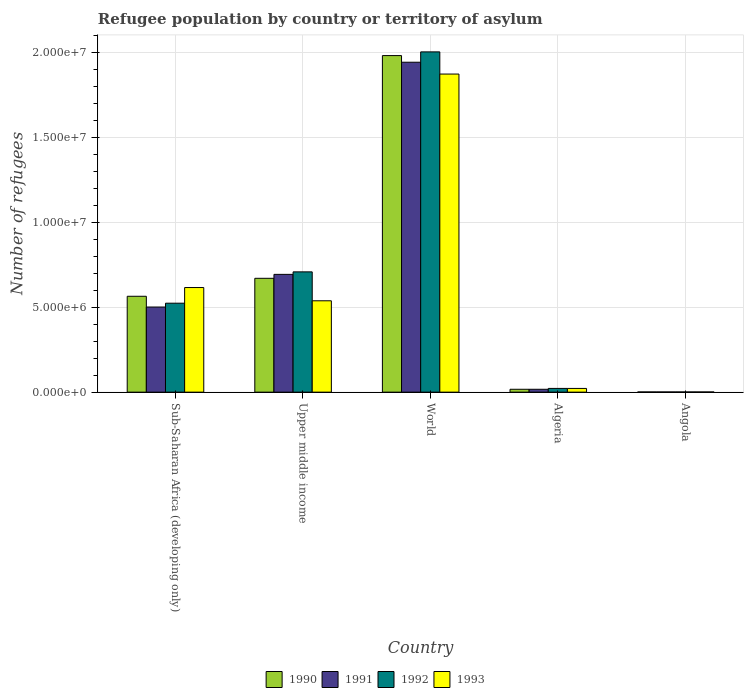Are the number of bars on each tick of the X-axis equal?
Offer a very short reply. Yes. What is the label of the 4th group of bars from the left?
Provide a short and direct response. Algeria. What is the number of refugees in 1991 in Upper middle income?
Offer a terse response. 6.93e+06. Across all countries, what is the maximum number of refugees in 1990?
Your answer should be very brief. 1.98e+07. Across all countries, what is the minimum number of refugees in 1991?
Your answer should be compact. 1.10e+04. In which country was the number of refugees in 1992 minimum?
Your answer should be compact. Angola. What is the total number of refugees in 1992 in the graph?
Make the answer very short. 3.26e+07. What is the difference between the number of refugees in 1993 in Angola and that in World?
Offer a terse response. -1.87e+07. What is the difference between the number of refugees in 1993 in Upper middle income and the number of refugees in 1990 in World?
Your answer should be compact. -1.44e+07. What is the average number of refugees in 1993 per country?
Keep it short and to the point. 6.10e+06. What is the ratio of the number of refugees in 1992 in Angola to that in Upper middle income?
Make the answer very short. 0. What is the difference between the highest and the second highest number of refugees in 1992?
Offer a terse response. -1.29e+07. What is the difference between the highest and the lowest number of refugees in 1992?
Provide a short and direct response. 2.00e+07. Is the sum of the number of refugees in 1992 in Algeria and Sub-Saharan Africa (developing only) greater than the maximum number of refugees in 1991 across all countries?
Your response must be concise. No. What does the 1st bar from the left in Algeria represents?
Offer a terse response. 1990. Is it the case that in every country, the sum of the number of refugees in 1992 and number of refugees in 1991 is greater than the number of refugees in 1990?
Keep it short and to the point. Yes. How many countries are there in the graph?
Your answer should be very brief. 5. Does the graph contain grids?
Make the answer very short. Yes. Where does the legend appear in the graph?
Your response must be concise. Bottom center. How many legend labels are there?
Offer a terse response. 4. How are the legend labels stacked?
Offer a terse response. Horizontal. What is the title of the graph?
Your answer should be very brief. Refugee population by country or territory of asylum. Does "2000" appear as one of the legend labels in the graph?
Your answer should be compact. No. What is the label or title of the Y-axis?
Keep it short and to the point. Number of refugees. What is the Number of refugees in 1990 in Sub-Saharan Africa (developing only)?
Make the answer very short. 5.64e+06. What is the Number of refugees of 1991 in Sub-Saharan Africa (developing only)?
Offer a terse response. 5.01e+06. What is the Number of refugees of 1992 in Sub-Saharan Africa (developing only)?
Your answer should be very brief. 5.23e+06. What is the Number of refugees in 1993 in Sub-Saharan Africa (developing only)?
Your response must be concise. 6.16e+06. What is the Number of refugees of 1990 in Upper middle income?
Provide a succinct answer. 6.70e+06. What is the Number of refugees in 1991 in Upper middle income?
Give a very brief answer. 6.93e+06. What is the Number of refugees of 1992 in Upper middle income?
Your answer should be very brief. 7.08e+06. What is the Number of refugees in 1993 in Upper middle income?
Provide a succinct answer. 5.38e+06. What is the Number of refugees in 1990 in World?
Keep it short and to the point. 1.98e+07. What is the Number of refugees in 1991 in World?
Offer a terse response. 1.94e+07. What is the Number of refugees of 1992 in World?
Your answer should be very brief. 2.00e+07. What is the Number of refugees in 1993 in World?
Offer a terse response. 1.87e+07. What is the Number of refugees in 1990 in Algeria?
Make the answer very short. 1.69e+05. What is the Number of refugees of 1991 in Algeria?
Offer a very short reply. 1.69e+05. What is the Number of refugees of 1992 in Algeria?
Provide a short and direct response. 2.19e+05. What is the Number of refugees in 1993 in Algeria?
Make the answer very short. 2.19e+05. What is the Number of refugees in 1990 in Angola?
Provide a short and direct response. 1.16e+04. What is the Number of refugees of 1991 in Angola?
Ensure brevity in your answer.  1.10e+04. What is the Number of refugees of 1992 in Angola?
Your answer should be very brief. 1.10e+04. What is the Number of refugees in 1993 in Angola?
Give a very brief answer. 1.09e+04. Across all countries, what is the maximum Number of refugees of 1990?
Give a very brief answer. 1.98e+07. Across all countries, what is the maximum Number of refugees of 1991?
Provide a short and direct response. 1.94e+07. Across all countries, what is the maximum Number of refugees of 1992?
Keep it short and to the point. 2.00e+07. Across all countries, what is the maximum Number of refugees in 1993?
Offer a very short reply. 1.87e+07. Across all countries, what is the minimum Number of refugees in 1990?
Your answer should be very brief. 1.16e+04. Across all countries, what is the minimum Number of refugees in 1991?
Provide a succinct answer. 1.10e+04. Across all countries, what is the minimum Number of refugees in 1992?
Make the answer very short. 1.10e+04. Across all countries, what is the minimum Number of refugees in 1993?
Make the answer very short. 1.09e+04. What is the total Number of refugees of 1990 in the graph?
Your answer should be compact. 3.23e+07. What is the total Number of refugees of 1991 in the graph?
Provide a short and direct response. 3.15e+07. What is the total Number of refugees of 1992 in the graph?
Offer a terse response. 3.26e+07. What is the total Number of refugees of 1993 in the graph?
Provide a short and direct response. 3.05e+07. What is the difference between the Number of refugees of 1990 in Sub-Saharan Africa (developing only) and that in Upper middle income?
Your answer should be very brief. -1.06e+06. What is the difference between the Number of refugees of 1991 in Sub-Saharan Africa (developing only) and that in Upper middle income?
Provide a succinct answer. -1.92e+06. What is the difference between the Number of refugees of 1992 in Sub-Saharan Africa (developing only) and that in Upper middle income?
Provide a short and direct response. -1.84e+06. What is the difference between the Number of refugees of 1993 in Sub-Saharan Africa (developing only) and that in Upper middle income?
Make the answer very short. 7.79e+05. What is the difference between the Number of refugees in 1990 in Sub-Saharan Africa (developing only) and that in World?
Your response must be concise. -1.42e+07. What is the difference between the Number of refugees of 1991 in Sub-Saharan Africa (developing only) and that in World?
Ensure brevity in your answer.  -1.44e+07. What is the difference between the Number of refugees of 1992 in Sub-Saharan Africa (developing only) and that in World?
Provide a succinct answer. -1.48e+07. What is the difference between the Number of refugees of 1993 in Sub-Saharan Africa (developing only) and that in World?
Provide a short and direct response. -1.26e+07. What is the difference between the Number of refugees of 1990 in Sub-Saharan Africa (developing only) and that in Algeria?
Keep it short and to the point. 5.47e+06. What is the difference between the Number of refugees of 1991 in Sub-Saharan Africa (developing only) and that in Algeria?
Offer a very short reply. 4.84e+06. What is the difference between the Number of refugees of 1992 in Sub-Saharan Africa (developing only) and that in Algeria?
Offer a very short reply. 5.01e+06. What is the difference between the Number of refugees in 1993 in Sub-Saharan Africa (developing only) and that in Algeria?
Ensure brevity in your answer.  5.94e+06. What is the difference between the Number of refugees of 1990 in Sub-Saharan Africa (developing only) and that in Angola?
Make the answer very short. 5.63e+06. What is the difference between the Number of refugees of 1991 in Sub-Saharan Africa (developing only) and that in Angola?
Offer a terse response. 5.00e+06. What is the difference between the Number of refugees of 1992 in Sub-Saharan Africa (developing only) and that in Angola?
Give a very brief answer. 5.22e+06. What is the difference between the Number of refugees of 1993 in Sub-Saharan Africa (developing only) and that in Angola?
Your answer should be very brief. 6.14e+06. What is the difference between the Number of refugees in 1990 in Upper middle income and that in World?
Your response must be concise. -1.31e+07. What is the difference between the Number of refugees of 1991 in Upper middle income and that in World?
Give a very brief answer. -1.25e+07. What is the difference between the Number of refugees in 1992 in Upper middle income and that in World?
Provide a succinct answer. -1.29e+07. What is the difference between the Number of refugees in 1993 in Upper middle income and that in World?
Your answer should be very brief. -1.33e+07. What is the difference between the Number of refugees in 1990 in Upper middle income and that in Algeria?
Provide a short and direct response. 6.53e+06. What is the difference between the Number of refugees of 1991 in Upper middle income and that in Algeria?
Give a very brief answer. 6.76e+06. What is the difference between the Number of refugees of 1992 in Upper middle income and that in Algeria?
Offer a terse response. 6.86e+06. What is the difference between the Number of refugees of 1993 in Upper middle income and that in Algeria?
Give a very brief answer. 5.16e+06. What is the difference between the Number of refugees in 1990 in Upper middle income and that in Angola?
Keep it short and to the point. 6.69e+06. What is the difference between the Number of refugees of 1991 in Upper middle income and that in Angola?
Your answer should be very brief. 6.92e+06. What is the difference between the Number of refugees of 1992 in Upper middle income and that in Angola?
Offer a terse response. 7.07e+06. What is the difference between the Number of refugees in 1993 in Upper middle income and that in Angola?
Offer a very short reply. 5.37e+06. What is the difference between the Number of refugees of 1990 in World and that in Algeria?
Keep it short and to the point. 1.96e+07. What is the difference between the Number of refugees in 1991 in World and that in Algeria?
Offer a very short reply. 1.92e+07. What is the difference between the Number of refugees of 1992 in World and that in Algeria?
Your answer should be very brief. 1.98e+07. What is the difference between the Number of refugees in 1993 in World and that in Algeria?
Keep it short and to the point. 1.85e+07. What is the difference between the Number of refugees of 1990 in World and that in Angola?
Provide a short and direct response. 1.98e+07. What is the difference between the Number of refugees in 1991 in World and that in Angola?
Your answer should be very brief. 1.94e+07. What is the difference between the Number of refugees in 1992 in World and that in Angola?
Keep it short and to the point. 2.00e+07. What is the difference between the Number of refugees in 1993 in World and that in Angola?
Your answer should be very brief. 1.87e+07. What is the difference between the Number of refugees in 1990 in Algeria and that in Angola?
Offer a terse response. 1.58e+05. What is the difference between the Number of refugees of 1991 in Algeria and that in Angola?
Offer a very short reply. 1.58e+05. What is the difference between the Number of refugees in 1992 in Algeria and that in Angola?
Offer a very short reply. 2.08e+05. What is the difference between the Number of refugees in 1993 in Algeria and that in Angola?
Offer a very short reply. 2.08e+05. What is the difference between the Number of refugees of 1990 in Sub-Saharan Africa (developing only) and the Number of refugees of 1991 in Upper middle income?
Provide a succinct answer. -1.29e+06. What is the difference between the Number of refugees in 1990 in Sub-Saharan Africa (developing only) and the Number of refugees in 1992 in Upper middle income?
Ensure brevity in your answer.  -1.44e+06. What is the difference between the Number of refugees in 1990 in Sub-Saharan Africa (developing only) and the Number of refugees in 1993 in Upper middle income?
Give a very brief answer. 2.65e+05. What is the difference between the Number of refugees in 1991 in Sub-Saharan Africa (developing only) and the Number of refugees in 1992 in Upper middle income?
Offer a very short reply. -2.07e+06. What is the difference between the Number of refugees in 1991 in Sub-Saharan Africa (developing only) and the Number of refugees in 1993 in Upper middle income?
Provide a succinct answer. -3.67e+05. What is the difference between the Number of refugees of 1992 in Sub-Saharan Africa (developing only) and the Number of refugees of 1993 in Upper middle income?
Ensure brevity in your answer.  -1.42e+05. What is the difference between the Number of refugees of 1990 in Sub-Saharan Africa (developing only) and the Number of refugees of 1991 in World?
Give a very brief answer. -1.38e+07. What is the difference between the Number of refugees of 1990 in Sub-Saharan Africa (developing only) and the Number of refugees of 1992 in World?
Your answer should be compact. -1.44e+07. What is the difference between the Number of refugees in 1990 in Sub-Saharan Africa (developing only) and the Number of refugees in 1993 in World?
Give a very brief answer. -1.31e+07. What is the difference between the Number of refugees in 1991 in Sub-Saharan Africa (developing only) and the Number of refugees in 1992 in World?
Offer a very short reply. -1.50e+07. What is the difference between the Number of refugees in 1991 in Sub-Saharan Africa (developing only) and the Number of refugees in 1993 in World?
Offer a terse response. -1.37e+07. What is the difference between the Number of refugees of 1992 in Sub-Saharan Africa (developing only) and the Number of refugees of 1993 in World?
Provide a succinct answer. -1.35e+07. What is the difference between the Number of refugees of 1990 in Sub-Saharan Africa (developing only) and the Number of refugees of 1991 in Algeria?
Your answer should be very brief. 5.47e+06. What is the difference between the Number of refugees of 1990 in Sub-Saharan Africa (developing only) and the Number of refugees of 1992 in Algeria?
Your answer should be very brief. 5.42e+06. What is the difference between the Number of refugees in 1990 in Sub-Saharan Africa (developing only) and the Number of refugees in 1993 in Algeria?
Provide a short and direct response. 5.42e+06. What is the difference between the Number of refugees of 1991 in Sub-Saharan Africa (developing only) and the Number of refugees of 1992 in Algeria?
Give a very brief answer. 4.79e+06. What is the difference between the Number of refugees in 1991 in Sub-Saharan Africa (developing only) and the Number of refugees in 1993 in Algeria?
Provide a short and direct response. 4.79e+06. What is the difference between the Number of refugees in 1992 in Sub-Saharan Africa (developing only) and the Number of refugees in 1993 in Algeria?
Make the answer very short. 5.02e+06. What is the difference between the Number of refugees of 1990 in Sub-Saharan Africa (developing only) and the Number of refugees of 1991 in Angola?
Your answer should be very brief. 5.63e+06. What is the difference between the Number of refugees in 1990 in Sub-Saharan Africa (developing only) and the Number of refugees in 1992 in Angola?
Offer a terse response. 5.63e+06. What is the difference between the Number of refugees of 1990 in Sub-Saharan Africa (developing only) and the Number of refugees of 1993 in Angola?
Provide a short and direct response. 5.63e+06. What is the difference between the Number of refugees in 1991 in Sub-Saharan Africa (developing only) and the Number of refugees in 1992 in Angola?
Offer a terse response. 5.00e+06. What is the difference between the Number of refugees of 1991 in Sub-Saharan Africa (developing only) and the Number of refugees of 1993 in Angola?
Give a very brief answer. 5.00e+06. What is the difference between the Number of refugees of 1992 in Sub-Saharan Africa (developing only) and the Number of refugees of 1993 in Angola?
Your response must be concise. 5.22e+06. What is the difference between the Number of refugees in 1990 in Upper middle income and the Number of refugees in 1991 in World?
Your answer should be compact. -1.27e+07. What is the difference between the Number of refugees in 1990 in Upper middle income and the Number of refugees in 1992 in World?
Give a very brief answer. -1.33e+07. What is the difference between the Number of refugees of 1990 in Upper middle income and the Number of refugees of 1993 in World?
Your answer should be very brief. -1.20e+07. What is the difference between the Number of refugees in 1991 in Upper middle income and the Number of refugees in 1992 in World?
Provide a short and direct response. -1.31e+07. What is the difference between the Number of refugees of 1991 in Upper middle income and the Number of refugees of 1993 in World?
Provide a short and direct response. -1.18e+07. What is the difference between the Number of refugees of 1992 in Upper middle income and the Number of refugees of 1993 in World?
Your answer should be compact. -1.16e+07. What is the difference between the Number of refugees in 1990 in Upper middle income and the Number of refugees in 1991 in Algeria?
Make the answer very short. 6.53e+06. What is the difference between the Number of refugees in 1990 in Upper middle income and the Number of refugees in 1992 in Algeria?
Provide a succinct answer. 6.48e+06. What is the difference between the Number of refugees in 1990 in Upper middle income and the Number of refugees in 1993 in Algeria?
Provide a short and direct response. 6.48e+06. What is the difference between the Number of refugees of 1991 in Upper middle income and the Number of refugees of 1992 in Algeria?
Your response must be concise. 6.71e+06. What is the difference between the Number of refugees in 1991 in Upper middle income and the Number of refugees in 1993 in Algeria?
Make the answer very short. 6.71e+06. What is the difference between the Number of refugees in 1992 in Upper middle income and the Number of refugees in 1993 in Algeria?
Give a very brief answer. 6.86e+06. What is the difference between the Number of refugees in 1990 in Upper middle income and the Number of refugees in 1991 in Angola?
Provide a short and direct response. 6.69e+06. What is the difference between the Number of refugees in 1990 in Upper middle income and the Number of refugees in 1992 in Angola?
Your answer should be very brief. 6.69e+06. What is the difference between the Number of refugees of 1990 in Upper middle income and the Number of refugees of 1993 in Angola?
Ensure brevity in your answer.  6.69e+06. What is the difference between the Number of refugees of 1991 in Upper middle income and the Number of refugees of 1992 in Angola?
Keep it short and to the point. 6.92e+06. What is the difference between the Number of refugees in 1991 in Upper middle income and the Number of refugees in 1993 in Angola?
Your response must be concise. 6.92e+06. What is the difference between the Number of refugees in 1992 in Upper middle income and the Number of refugees in 1993 in Angola?
Make the answer very short. 7.07e+06. What is the difference between the Number of refugees of 1990 in World and the Number of refugees of 1991 in Algeria?
Give a very brief answer. 1.96e+07. What is the difference between the Number of refugees of 1990 in World and the Number of refugees of 1992 in Algeria?
Your answer should be compact. 1.96e+07. What is the difference between the Number of refugees of 1990 in World and the Number of refugees of 1993 in Algeria?
Your response must be concise. 1.96e+07. What is the difference between the Number of refugees of 1991 in World and the Number of refugees of 1992 in Algeria?
Keep it short and to the point. 1.92e+07. What is the difference between the Number of refugees of 1991 in World and the Number of refugees of 1993 in Algeria?
Ensure brevity in your answer.  1.92e+07. What is the difference between the Number of refugees of 1992 in World and the Number of refugees of 1993 in Algeria?
Provide a succinct answer. 1.98e+07. What is the difference between the Number of refugees in 1990 in World and the Number of refugees in 1991 in Angola?
Give a very brief answer. 1.98e+07. What is the difference between the Number of refugees of 1990 in World and the Number of refugees of 1992 in Angola?
Offer a very short reply. 1.98e+07. What is the difference between the Number of refugees of 1990 in World and the Number of refugees of 1993 in Angola?
Make the answer very short. 1.98e+07. What is the difference between the Number of refugees in 1991 in World and the Number of refugees in 1992 in Angola?
Offer a terse response. 1.94e+07. What is the difference between the Number of refugees in 1991 in World and the Number of refugees in 1993 in Angola?
Give a very brief answer. 1.94e+07. What is the difference between the Number of refugees in 1992 in World and the Number of refugees in 1993 in Angola?
Provide a short and direct response. 2.00e+07. What is the difference between the Number of refugees of 1990 in Algeria and the Number of refugees of 1991 in Angola?
Your answer should be very brief. 1.58e+05. What is the difference between the Number of refugees of 1990 in Algeria and the Number of refugees of 1992 in Angola?
Make the answer very short. 1.58e+05. What is the difference between the Number of refugees of 1990 in Algeria and the Number of refugees of 1993 in Angola?
Give a very brief answer. 1.58e+05. What is the difference between the Number of refugees of 1991 in Algeria and the Number of refugees of 1992 in Angola?
Provide a succinct answer. 1.58e+05. What is the difference between the Number of refugees of 1991 in Algeria and the Number of refugees of 1993 in Angola?
Offer a terse response. 1.58e+05. What is the difference between the Number of refugees in 1992 in Algeria and the Number of refugees in 1993 in Angola?
Your answer should be very brief. 2.08e+05. What is the average Number of refugees of 1990 per country?
Provide a short and direct response. 6.47e+06. What is the average Number of refugees of 1991 per country?
Offer a terse response. 6.31e+06. What is the average Number of refugees of 1992 per country?
Your response must be concise. 6.51e+06. What is the average Number of refugees of 1993 per country?
Give a very brief answer. 6.10e+06. What is the difference between the Number of refugees of 1990 and Number of refugees of 1991 in Sub-Saharan Africa (developing only)?
Your answer should be compact. 6.33e+05. What is the difference between the Number of refugees in 1990 and Number of refugees in 1992 in Sub-Saharan Africa (developing only)?
Make the answer very short. 4.07e+05. What is the difference between the Number of refugees in 1990 and Number of refugees in 1993 in Sub-Saharan Africa (developing only)?
Your response must be concise. -5.14e+05. What is the difference between the Number of refugees in 1991 and Number of refugees in 1992 in Sub-Saharan Africa (developing only)?
Keep it short and to the point. -2.25e+05. What is the difference between the Number of refugees of 1991 and Number of refugees of 1993 in Sub-Saharan Africa (developing only)?
Offer a very short reply. -1.15e+06. What is the difference between the Number of refugees of 1992 and Number of refugees of 1993 in Sub-Saharan Africa (developing only)?
Offer a terse response. -9.21e+05. What is the difference between the Number of refugees in 1990 and Number of refugees in 1991 in Upper middle income?
Ensure brevity in your answer.  -2.32e+05. What is the difference between the Number of refugees in 1990 and Number of refugees in 1992 in Upper middle income?
Your response must be concise. -3.79e+05. What is the difference between the Number of refugees of 1990 and Number of refugees of 1993 in Upper middle income?
Your answer should be compact. 1.32e+06. What is the difference between the Number of refugees in 1991 and Number of refugees in 1992 in Upper middle income?
Keep it short and to the point. -1.47e+05. What is the difference between the Number of refugees of 1991 and Number of refugees of 1993 in Upper middle income?
Give a very brief answer. 1.56e+06. What is the difference between the Number of refugees of 1992 and Number of refugees of 1993 in Upper middle income?
Your answer should be compact. 1.70e+06. What is the difference between the Number of refugees in 1990 and Number of refugees in 1991 in World?
Offer a very short reply. 3.91e+05. What is the difference between the Number of refugees in 1990 and Number of refugees in 1992 in World?
Your response must be concise. -2.18e+05. What is the difference between the Number of refugees of 1990 and Number of refugees of 1993 in World?
Give a very brief answer. 1.09e+06. What is the difference between the Number of refugees in 1991 and Number of refugees in 1992 in World?
Provide a short and direct response. -6.09e+05. What is the difference between the Number of refugees in 1991 and Number of refugees in 1993 in World?
Offer a terse response. 6.96e+05. What is the difference between the Number of refugees of 1992 and Number of refugees of 1993 in World?
Offer a terse response. 1.30e+06. What is the difference between the Number of refugees in 1990 and Number of refugees in 1991 in Algeria?
Ensure brevity in your answer.  -14. What is the difference between the Number of refugees in 1990 and Number of refugees in 1992 in Algeria?
Your answer should be compact. -5.02e+04. What is the difference between the Number of refugees in 1990 and Number of refugees in 1993 in Algeria?
Keep it short and to the point. -5.00e+04. What is the difference between the Number of refugees in 1991 and Number of refugees in 1992 in Algeria?
Keep it short and to the point. -5.02e+04. What is the difference between the Number of refugees in 1991 and Number of refugees in 1993 in Algeria?
Offer a very short reply. -4.99e+04. What is the difference between the Number of refugees in 1992 and Number of refugees in 1993 in Algeria?
Make the answer very short. 247. What is the difference between the Number of refugees of 1990 and Number of refugees of 1991 in Angola?
Your answer should be very brief. 535. What is the difference between the Number of refugees in 1990 and Number of refugees in 1992 in Angola?
Keep it short and to the point. 555. What is the difference between the Number of refugees of 1990 and Number of refugees of 1993 in Angola?
Offer a very short reply. 679. What is the difference between the Number of refugees of 1991 and Number of refugees of 1992 in Angola?
Keep it short and to the point. 20. What is the difference between the Number of refugees of 1991 and Number of refugees of 1993 in Angola?
Keep it short and to the point. 144. What is the difference between the Number of refugees in 1992 and Number of refugees in 1993 in Angola?
Give a very brief answer. 124. What is the ratio of the Number of refugees of 1990 in Sub-Saharan Africa (developing only) to that in Upper middle income?
Offer a terse response. 0.84. What is the ratio of the Number of refugees of 1991 in Sub-Saharan Africa (developing only) to that in Upper middle income?
Keep it short and to the point. 0.72. What is the ratio of the Number of refugees in 1992 in Sub-Saharan Africa (developing only) to that in Upper middle income?
Your answer should be compact. 0.74. What is the ratio of the Number of refugees in 1993 in Sub-Saharan Africa (developing only) to that in Upper middle income?
Ensure brevity in your answer.  1.15. What is the ratio of the Number of refugees of 1990 in Sub-Saharan Africa (developing only) to that in World?
Keep it short and to the point. 0.28. What is the ratio of the Number of refugees of 1991 in Sub-Saharan Africa (developing only) to that in World?
Ensure brevity in your answer.  0.26. What is the ratio of the Number of refugees of 1992 in Sub-Saharan Africa (developing only) to that in World?
Your response must be concise. 0.26. What is the ratio of the Number of refugees of 1993 in Sub-Saharan Africa (developing only) to that in World?
Make the answer very short. 0.33. What is the ratio of the Number of refugees in 1990 in Sub-Saharan Africa (developing only) to that in Algeria?
Your answer should be compact. 33.36. What is the ratio of the Number of refugees of 1991 in Sub-Saharan Africa (developing only) to that in Algeria?
Make the answer very short. 29.62. What is the ratio of the Number of refugees in 1992 in Sub-Saharan Africa (developing only) to that in Algeria?
Offer a terse response. 23.87. What is the ratio of the Number of refugees of 1993 in Sub-Saharan Africa (developing only) to that in Algeria?
Your response must be concise. 28.1. What is the ratio of the Number of refugees of 1990 in Sub-Saharan Africa (developing only) to that in Angola?
Provide a succinct answer. 488.16. What is the ratio of the Number of refugees in 1991 in Sub-Saharan Africa (developing only) to that in Angola?
Your response must be concise. 454.45. What is the ratio of the Number of refugees in 1992 in Sub-Saharan Africa (developing only) to that in Angola?
Your response must be concise. 475.76. What is the ratio of the Number of refugees in 1993 in Sub-Saharan Africa (developing only) to that in Angola?
Your response must be concise. 565.88. What is the ratio of the Number of refugees in 1990 in Upper middle income to that in World?
Your response must be concise. 0.34. What is the ratio of the Number of refugees in 1991 in Upper middle income to that in World?
Provide a short and direct response. 0.36. What is the ratio of the Number of refugees in 1992 in Upper middle income to that in World?
Offer a very short reply. 0.35. What is the ratio of the Number of refugees of 1993 in Upper middle income to that in World?
Your response must be concise. 0.29. What is the ratio of the Number of refugees in 1990 in Upper middle income to that in Algeria?
Provide a short and direct response. 39.62. What is the ratio of the Number of refugees of 1991 in Upper middle income to that in Algeria?
Offer a very short reply. 40.98. What is the ratio of the Number of refugees in 1992 in Upper middle income to that in Algeria?
Ensure brevity in your answer.  32.28. What is the ratio of the Number of refugees of 1993 in Upper middle income to that in Algeria?
Make the answer very short. 24.54. What is the ratio of the Number of refugees in 1990 in Upper middle income to that in Angola?
Offer a terse response. 579.7. What is the ratio of the Number of refugees of 1991 in Upper middle income to that in Angola?
Provide a short and direct response. 628.87. What is the ratio of the Number of refugees of 1992 in Upper middle income to that in Angola?
Offer a terse response. 643.38. What is the ratio of the Number of refugees in 1993 in Upper middle income to that in Angola?
Provide a succinct answer. 494.24. What is the ratio of the Number of refugees of 1990 in World to that in Algeria?
Your answer should be compact. 117.12. What is the ratio of the Number of refugees in 1991 in World to that in Algeria?
Provide a short and direct response. 114.8. What is the ratio of the Number of refugees in 1992 in World to that in Algeria?
Offer a terse response. 91.3. What is the ratio of the Number of refugees of 1993 in World to that in Algeria?
Keep it short and to the point. 85.45. What is the ratio of the Number of refugees of 1990 in World to that in Angola?
Make the answer very short. 1713.74. What is the ratio of the Number of refugees in 1991 in World to that in Angola?
Offer a terse response. 1761.47. What is the ratio of the Number of refugees in 1992 in World to that in Angola?
Your answer should be very brief. 1819.99. What is the ratio of the Number of refugees in 1993 in World to that in Angola?
Your answer should be compact. 1720.81. What is the ratio of the Number of refugees in 1990 in Algeria to that in Angola?
Keep it short and to the point. 14.63. What is the ratio of the Number of refugees of 1991 in Algeria to that in Angola?
Your answer should be compact. 15.34. What is the ratio of the Number of refugees in 1992 in Algeria to that in Angola?
Make the answer very short. 19.93. What is the ratio of the Number of refugees in 1993 in Algeria to that in Angola?
Ensure brevity in your answer.  20.14. What is the difference between the highest and the second highest Number of refugees of 1990?
Your answer should be compact. 1.31e+07. What is the difference between the highest and the second highest Number of refugees of 1991?
Provide a short and direct response. 1.25e+07. What is the difference between the highest and the second highest Number of refugees of 1992?
Your answer should be compact. 1.29e+07. What is the difference between the highest and the second highest Number of refugees of 1993?
Your response must be concise. 1.26e+07. What is the difference between the highest and the lowest Number of refugees in 1990?
Make the answer very short. 1.98e+07. What is the difference between the highest and the lowest Number of refugees of 1991?
Provide a short and direct response. 1.94e+07. What is the difference between the highest and the lowest Number of refugees in 1992?
Offer a very short reply. 2.00e+07. What is the difference between the highest and the lowest Number of refugees of 1993?
Offer a very short reply. 1.87e+07. 